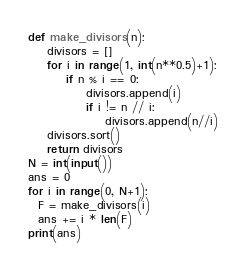<code> <loc_0><loc_0><loc_500><loc_500><_Python_>def make_divisors(n):
    divisors = []
    for i in range(1, int(n**0.5)+1):
        if n % i == 0:
            divisors.append(i)
            if i != n // i:
                divisors.append(n//i)
    divisors.sort()
    return divisors
N = int(input())
ans = 0
for i in range(0, N+1):
  F = make_divisors(i)
  ans += i * len(F)
print(ans)</code> 